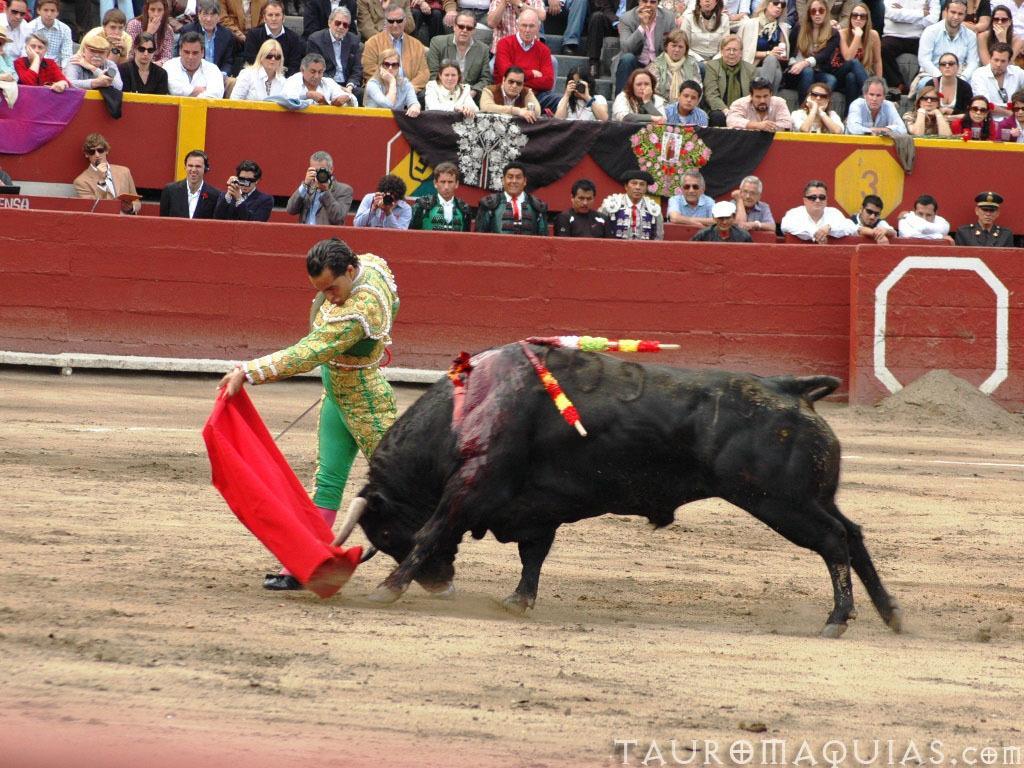Could you give a brief overview of what you see in this image? In this image we can see a bull on the ground. We can also see a person standing beside it holding a red carpet and a stick. On the backside we can see a heap of sand and a group of people sitting beside the fence. In that some are holding the cameras. 